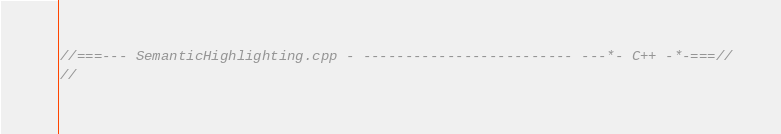Convert code to text. <code><loc_0><loc_0><loc_500><loc_500><_C++_>//===--- SemanticHighlighting.cpp - ------------------------- ---*- C++ -*-===//
//</code> 